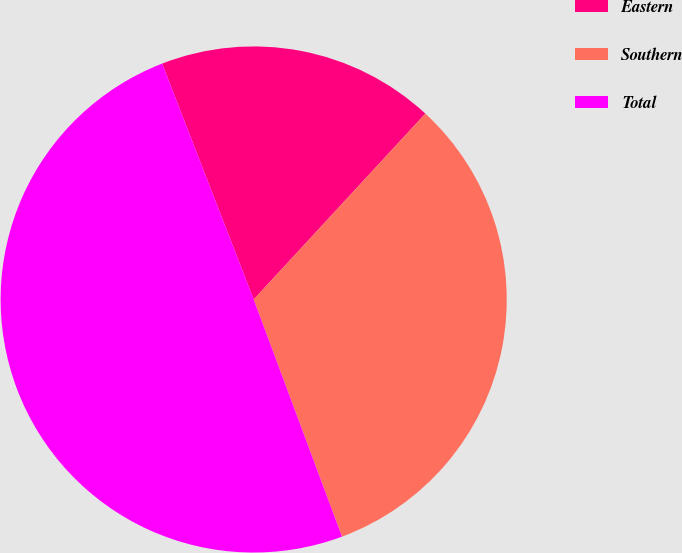<chart> <loc_0><loc_0><loc_500><loc_500><pie_chart><fcel>Eastern<fcel>Southern<fcel>Total<nl><fcel>17.76%<fcel>32.46%<fcel>49.78%<nl></chart> 